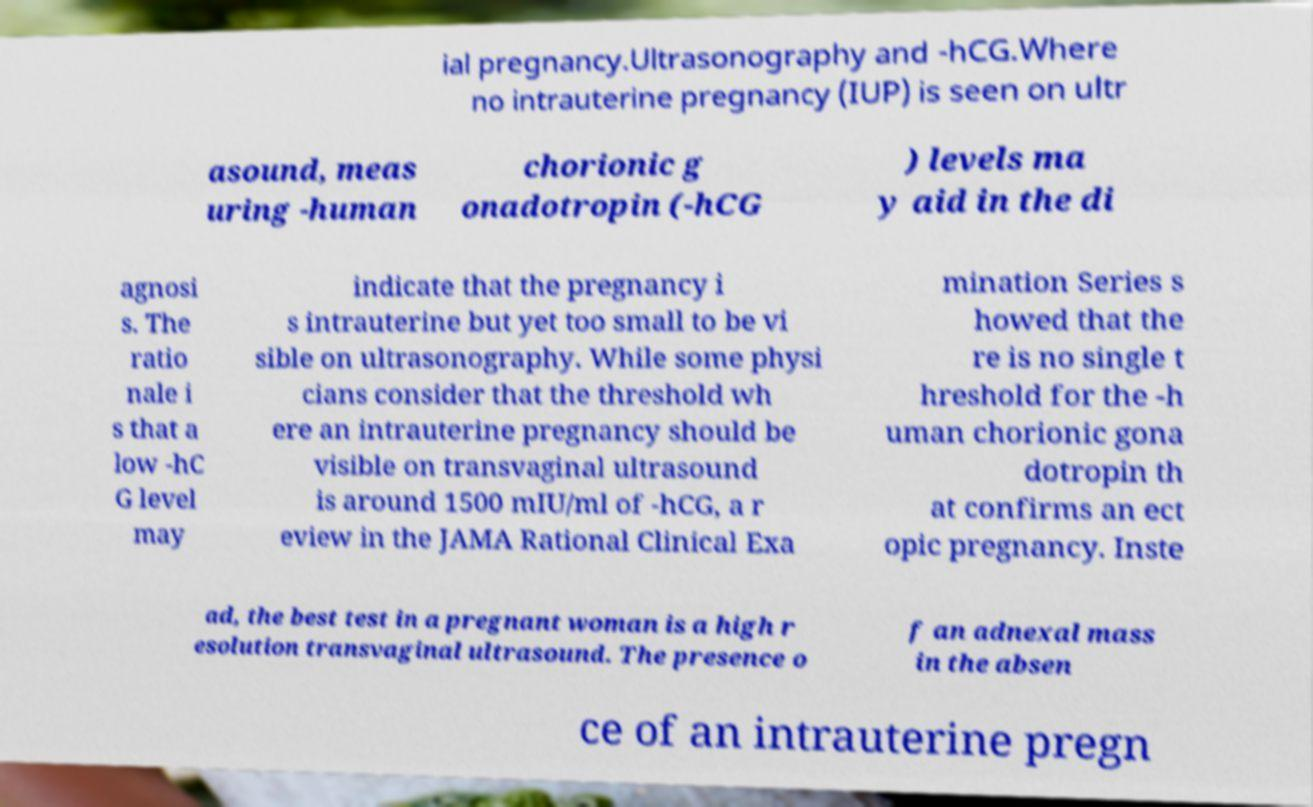Please read and relay the text visible in this image. What does it say? ial pregnancy.Ultrasonography and -hCG.Where no intrauterine pregnancy (IUP) is seen on ultr asound, meas uring -human chorionic g onadotropin (-hCG ) levels ma y aid in the di agnosi s. The ratio nale i s that a low -hC G level may indicate that the pregnancy i s intrauterine but yet too small to be vi sible on ultrasonography. While some physi cians consider that the threshold wh ere an intrauterine pregnancy should be visible on transvaginal ultrasound is around 1500 mIU/ml of -hCG, a r eview in the JAMA Rational Clinical Exa mination Series s howed that the re is no single t hreshold for the -h uman chorionic gona dotropin th at confirms an ect opic pregnancy. Inste ad, the best test in a pregnant woman is a high r esolution transvaginal ultrasound. The presence o f an adnexal mass in the absen ce of an intrauterine pregn 